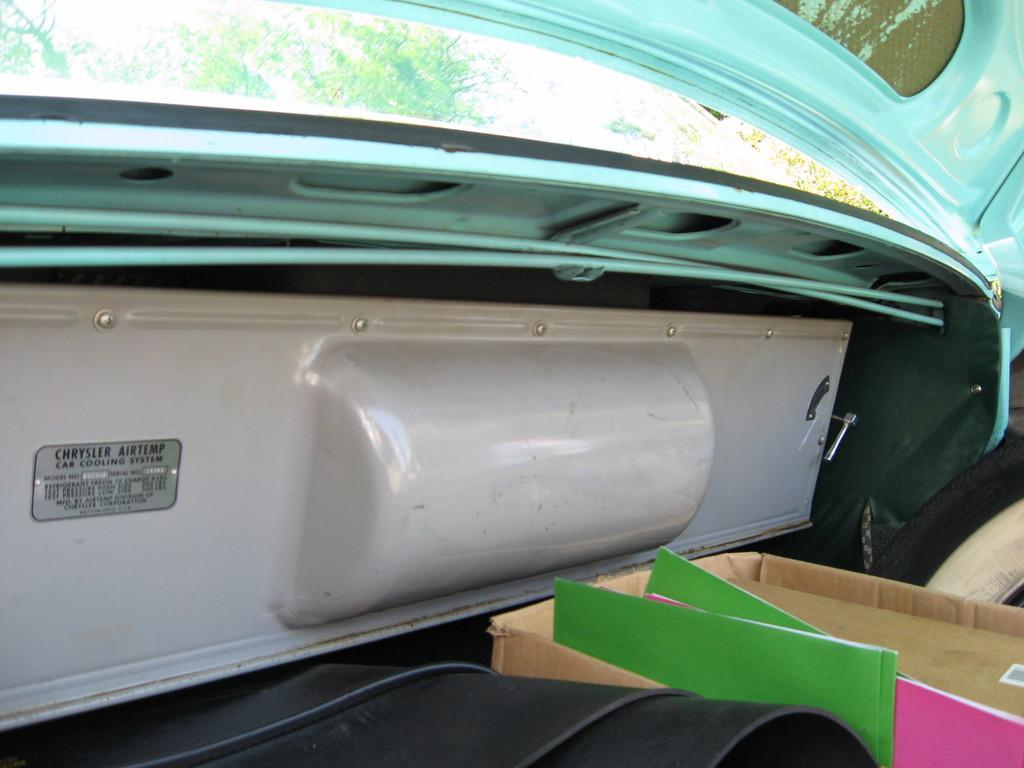Describe this image in one or two sentences. This is the picture of a vehicle. In this image there is a cardboard box and there are files and some other objects inside the vehicle. At the top there are trees. 